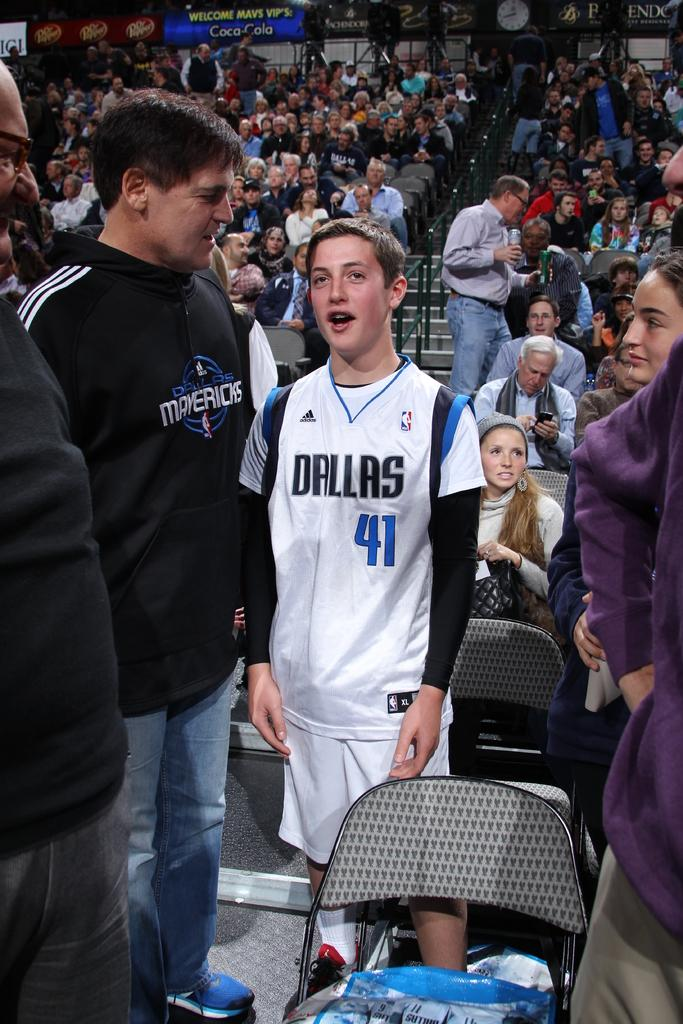Provide a one-sentence caption for the provided image. Boy wearing a basketball jersey which says Dallas number 41. 